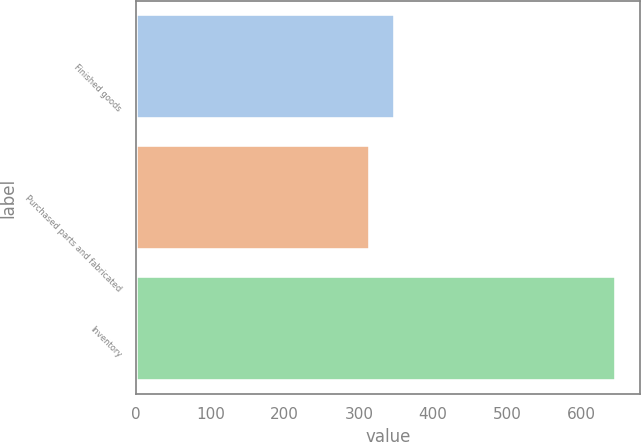Convert chart to OTSL. <chart><loc_0><loc_0><loc_500><loc_500><bar_chart><fcel>Finished goods<fcel>Purchased parts and fabricated<fcel>Inventory<nl><fcel>348.1<fcel>315<fcel>646<nl></chart> 